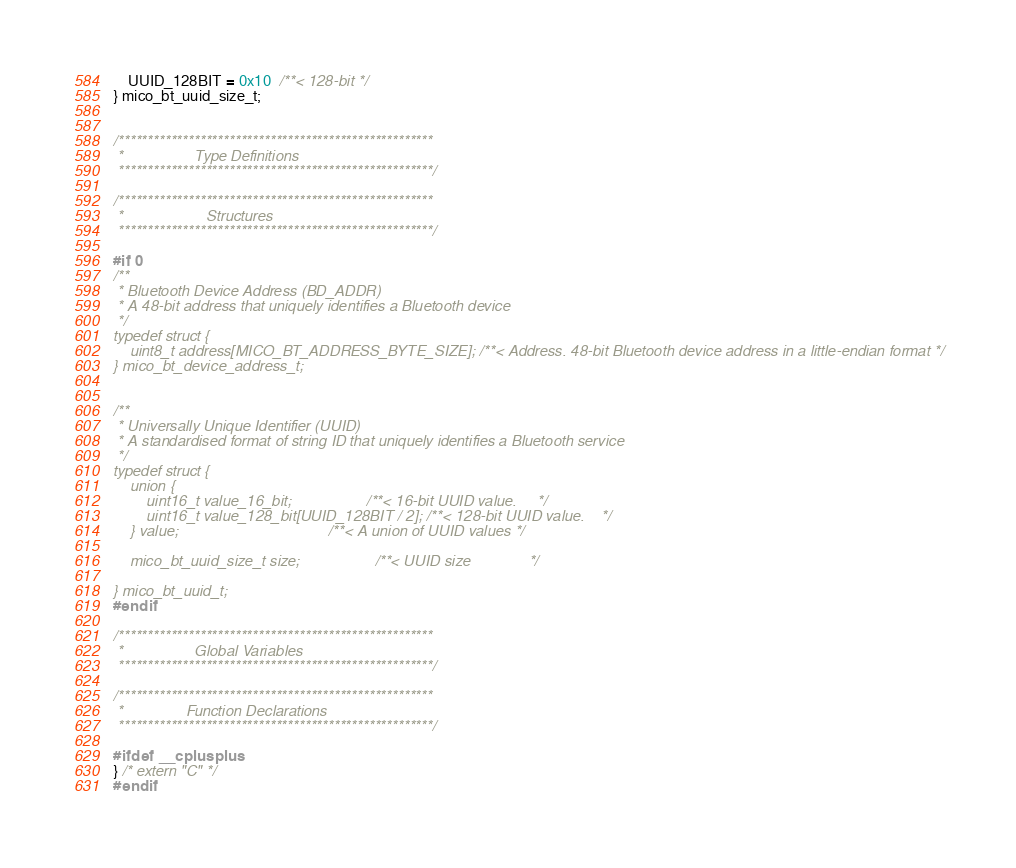<code> <loc_0><loc_0><loc_500><loc_500><_C_>    UUID_128BIT = 0x10  /**< 128-bit */
} mico_bt_uuid_size_t;


/******************************************************
 *                 Type Definitions
 ******************************************************/

/******************************************************
 *                    Structures
 ******************************************************/

#if 0
/**
 * Bluetooth Device Address (BD_ADDR)
 * A 48-bit address that uniquely identifies a Bluetooth device
 */
typedef struct {
    uint8_t address[MICO_BT_ADDRESS_BYTE_SIZE]; /**< Address. 48-bit Bluetooth device address in a little-endian format */
} mico_bt_device_address_t;


/**
 * Universally Unique Identifier (UUID)
 * A standardised format of string ID that uniquely identifies a Bluetooth service
 */
typedef struct {
    union {
        uint16_t value_16_bit;                  /**< 16-bit UUID value.     */
        uint16_t value_128_bit[UUID_128BIT / 2]; /**< 128-bit UUID value.    */
    } value;                                    /**< A union of UUID values */

    mico_bt_uuid_size_t size;                  /**< UUID size              */

} mico_bt_uuid_t;
#endif

/******************************************************
 *                 Global Variables
 ******************************************************/

/******************************************************
 *               Function Declarations
 ******************************************************/

#ifdef __cplusplus
} /* extern "C" */
#endif
</code> 